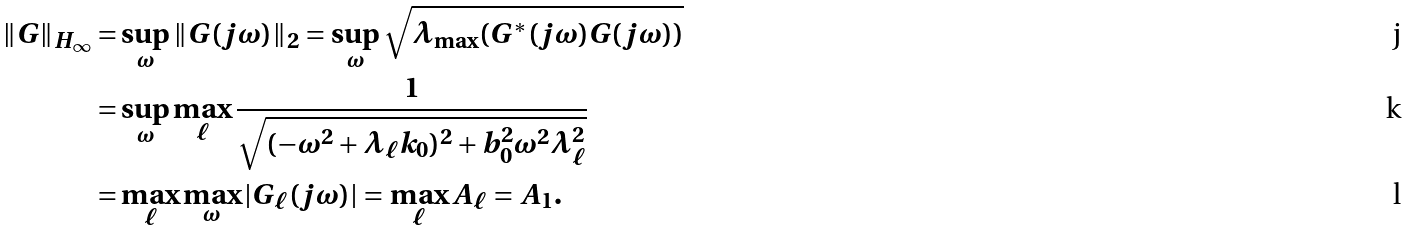<formula> <loc_0><loc_0><loc_500><loc_500>\| G \| _ { H _ { \infty } } = & \sup _ { \omega } \| G ( j \omega ) \| _ { 2 } = \sup _ { \omega } \sqrt { \lambda _ { \max } ( G ^ { * } ( j \omega ) G ( j \omega ) ) } \\ = & \sup _ { \omega } \max _ { \ell } \frac { 1 } { \sqrt { ( - \omega ^ { 2 } + \lambda _ { \ell } k _ { 0 } ) ^ { 2 } + b _ { 0 } ^ { 2 } \omega ^ { 2 } \lambda _ { \ell } ^ { 2 } } } \\ = & \max _ { \ell } \max _ { \omega } | G _ { \ell } ( j \omega ) | = \max _ { \ell } A _ { \ell } = A _ { 1 } .</formula> 